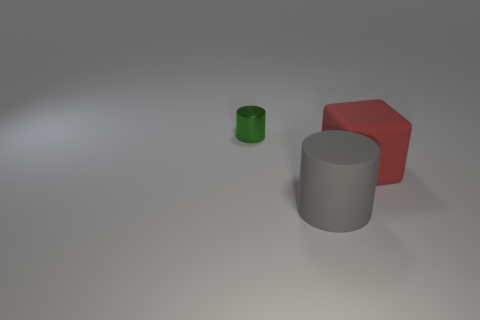What color is the cylinder in front of the green metallic object?
Provide a short and direct response. Gray. Do the cylinder in front of the small shiny object and the object that is left of the gray matte object have the same size?
Keep it short and to the point. No. What number of things are either tiny green things or red matte objects?
Keep it short and to the point. 2. What is the thing that is to the left of the big rubber object to the left of the large cube made of?
Your answer should be compact. Metal. What number of green things have the same shape as the gray object?
Your response must be concise. 1. Are there any big cylinders of the same color as the small object?
Provide a short and direct response. No. How many things are things in front of the tiny shiny cylinder or things that are in front of the green thing?
Your answer should be very brief. 2. There is a big rubber thing that is to the right of the rubber cylinder; is there a green metal object in front of it?
Offer a very short reply. No. What shape is the red thing that is the same size as the matte cylinder?
Provide a succinct answer. Cube. How many objects are objects that are behind the big cylinder or gray matte things?
Your answer should be very brief. 3. 